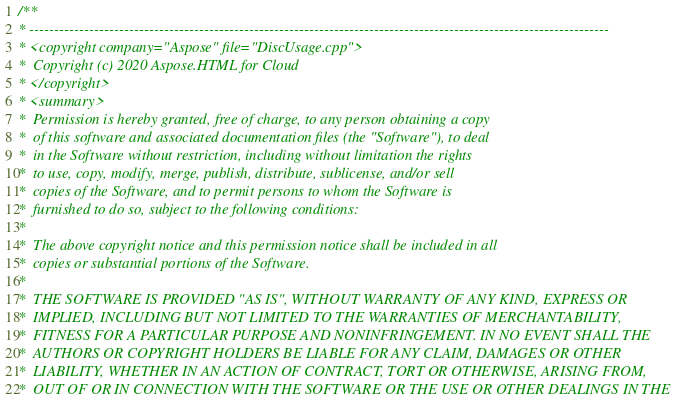<code> <loc_0><loc_0><loc_500><loc_500><_C++_>/**
* --------------------------------------------------------------------------------------------------------------------
* <copyright company="Aspose" file="DiscUsage.cpp">
*  Copyright (c) 2020 Aspose.HTML for Cloud
* </copyright>
* <summary>
*  Permission is hereby granted, free of charge, to any person obtaining a copy
*  of this software and associated documentation files (the "Software"), to deal
*  in the Software without restriction, including without limitation the rights
*  to use, copy, modify, merge, publish, distribute, sublicense, and/or sell
*  copies of the Software, and to permit persons to whom the Software is
*  furnished to do so, subject to the following conditions:
*
*  The above copyright notice and this permission notice shall be included in all
*  copies or substantial portions of the Software.
*
*  THE SOFTWARE IS PROVIDED "AS IS", WITHOUT WARRANTY OF ANY KIND, EXPRESS OR
*  IMPLIED, INCLUDING BUT NOT LIMITED TO THE WARRANTIES OF MERCHANTABILITY,
*  FITNESS FOR A PARTICULAR PURPOSE AND NONINFRINGEMENT. IN NO EVENT SHALL THE
*  AUTHORS OR COPYRIGHT HOLDERS BE LIABLE FOR ANY CLAIM, DAMAGES OR OTHER
*  LIABILITY, WHETHER IN AN ACTION OF CONTRACT, TORT OR OTHERWISE, ARISING FROM,
*  OUT OF OR IN CONNECTION WITH THE SOFTWARE OR THE USE OR OTHER DEALINGS IN THE</code> 